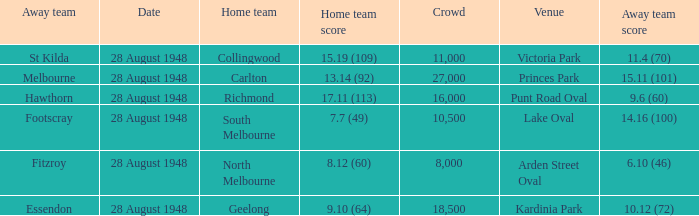What home team has a team score of 8.12 (60)? North Melbourne. 